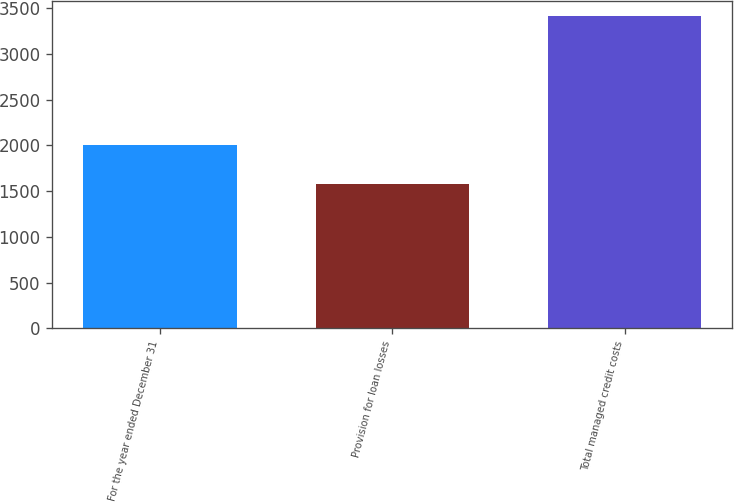Convert chart. <chart><loc_0><loc_0><loc_500><loc_500><bar_chart><fcel>For the year ended December 31<fcel>Provision for loan losses<fcel>Total managed credit costs<nl><fcel>2003<fcel>1579<fcel>3410<nl></chart> 